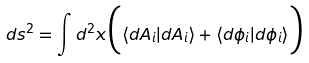<formula> <loc_0><loc_0><loc_500><loc_500>d s ^ { 2 } = \int d ^ { 2 } x \Big { ( } \langle d A _ { i } | d A _ { i } \rangle + \langle d \phi _ { i } | d \phi _ { i } \rangle \Big { ) }</formula> 